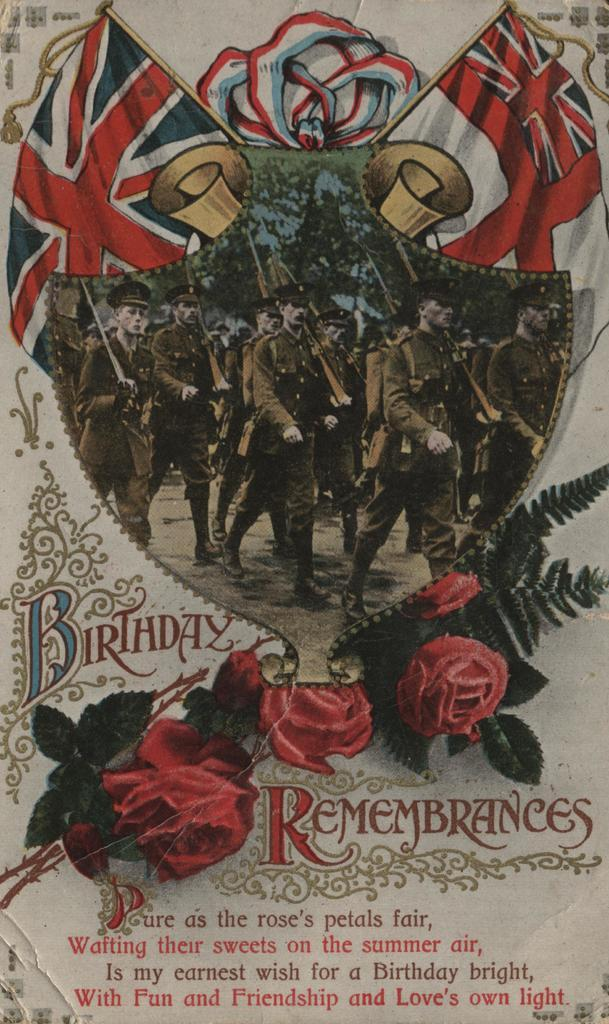<image>
Describe the image concisely. Poster showing soldiers marchine and the words "Birthday Remembrances" right under it. 